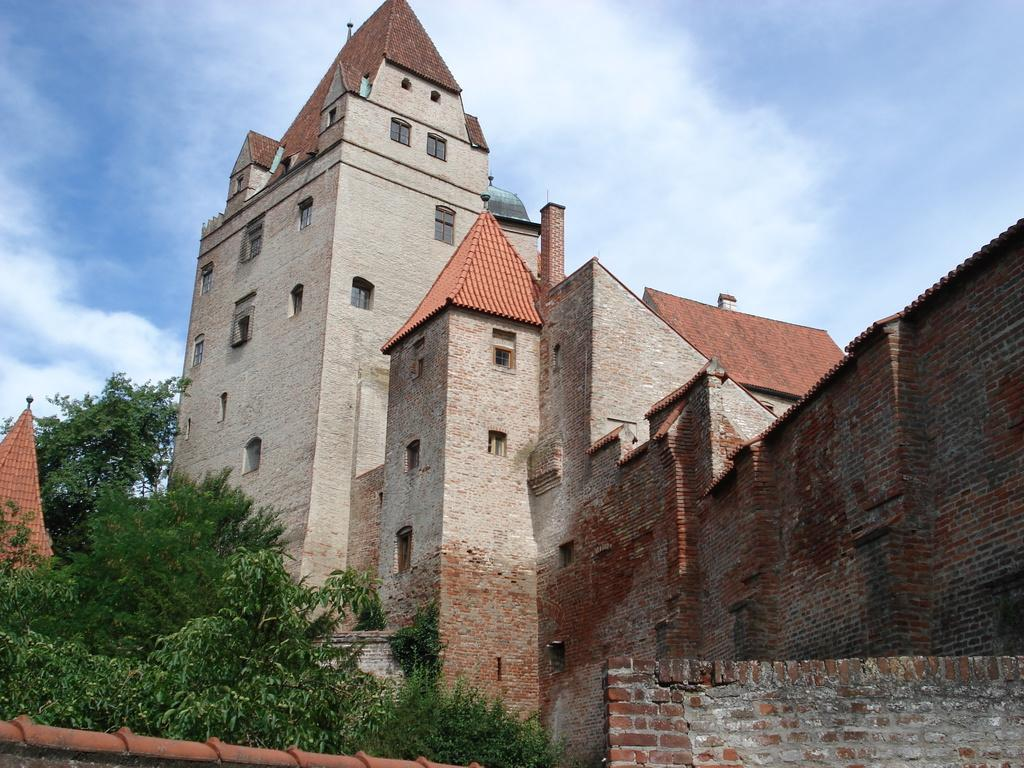What type of natural elements can be seen in the image? There are trees in the image. What type of man-made structure is present in the image? There is a compound wall in the image. What other man-made structures can be seen in the image? There are buildings in the image. What is visible in the background of the image? The sky is visible in the background of the image. Where can you purchase a ticket for the meeting in the image? There is no mention of a meeting or a ticket in the image. How many hills are visible in the image? There are no hills present in the image. 